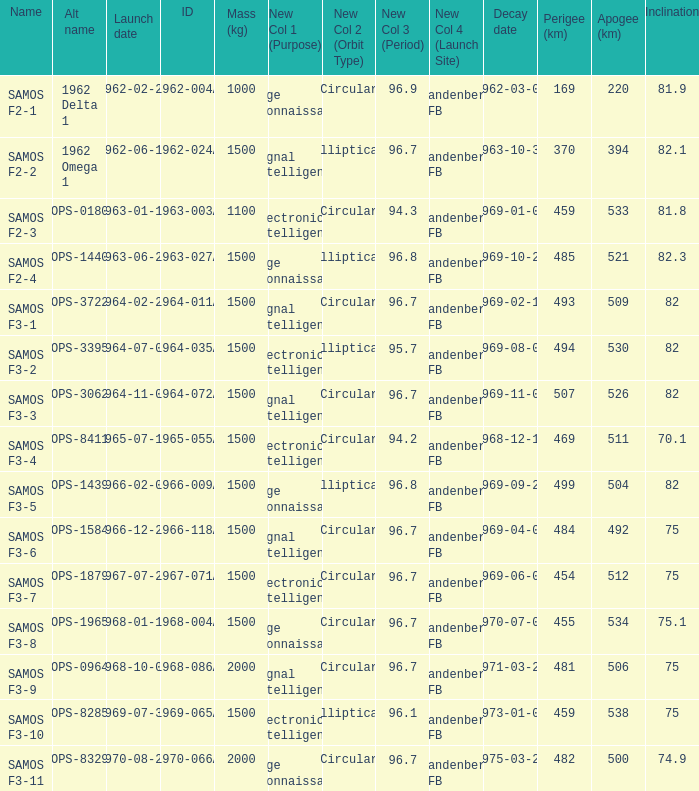What is the inclination when the alt name is OPS-1584? 75.0. 